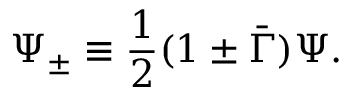<formula> <loc_0><loc_0><loc_500><loc_500>\Psi _ { \pm } \equiv \frac { 1 } { 2 } ( 1 \pm \bar { \Gamma } ) \Psi .</formula> 